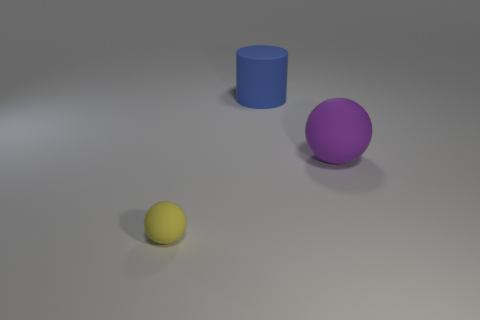Add 3 tiny rubber objects. How many objects exist? 6 Subtract 2 spheres. How many spheres are left? 0 Subtract all purple spheres. How many spheres are left? 1 Subtract all cylinders. How many objects are left? 2 Subtract all blue cubes. How many brown cylinders are left? 0 Subtract all yellow blocks. Subtract all big matte spheres. How many objects are left? 2 Add 3 big rubber spheres. How many big rubber spheres are left? 4 Add 2 big purple rubber balls. How many big purple rubber balls exist? 3 Subtract 0 blue cubes. How many objects are left? 3 Subtract all purple cylinders. Subtract all cyan spheres. How many cylinders are left? 1 